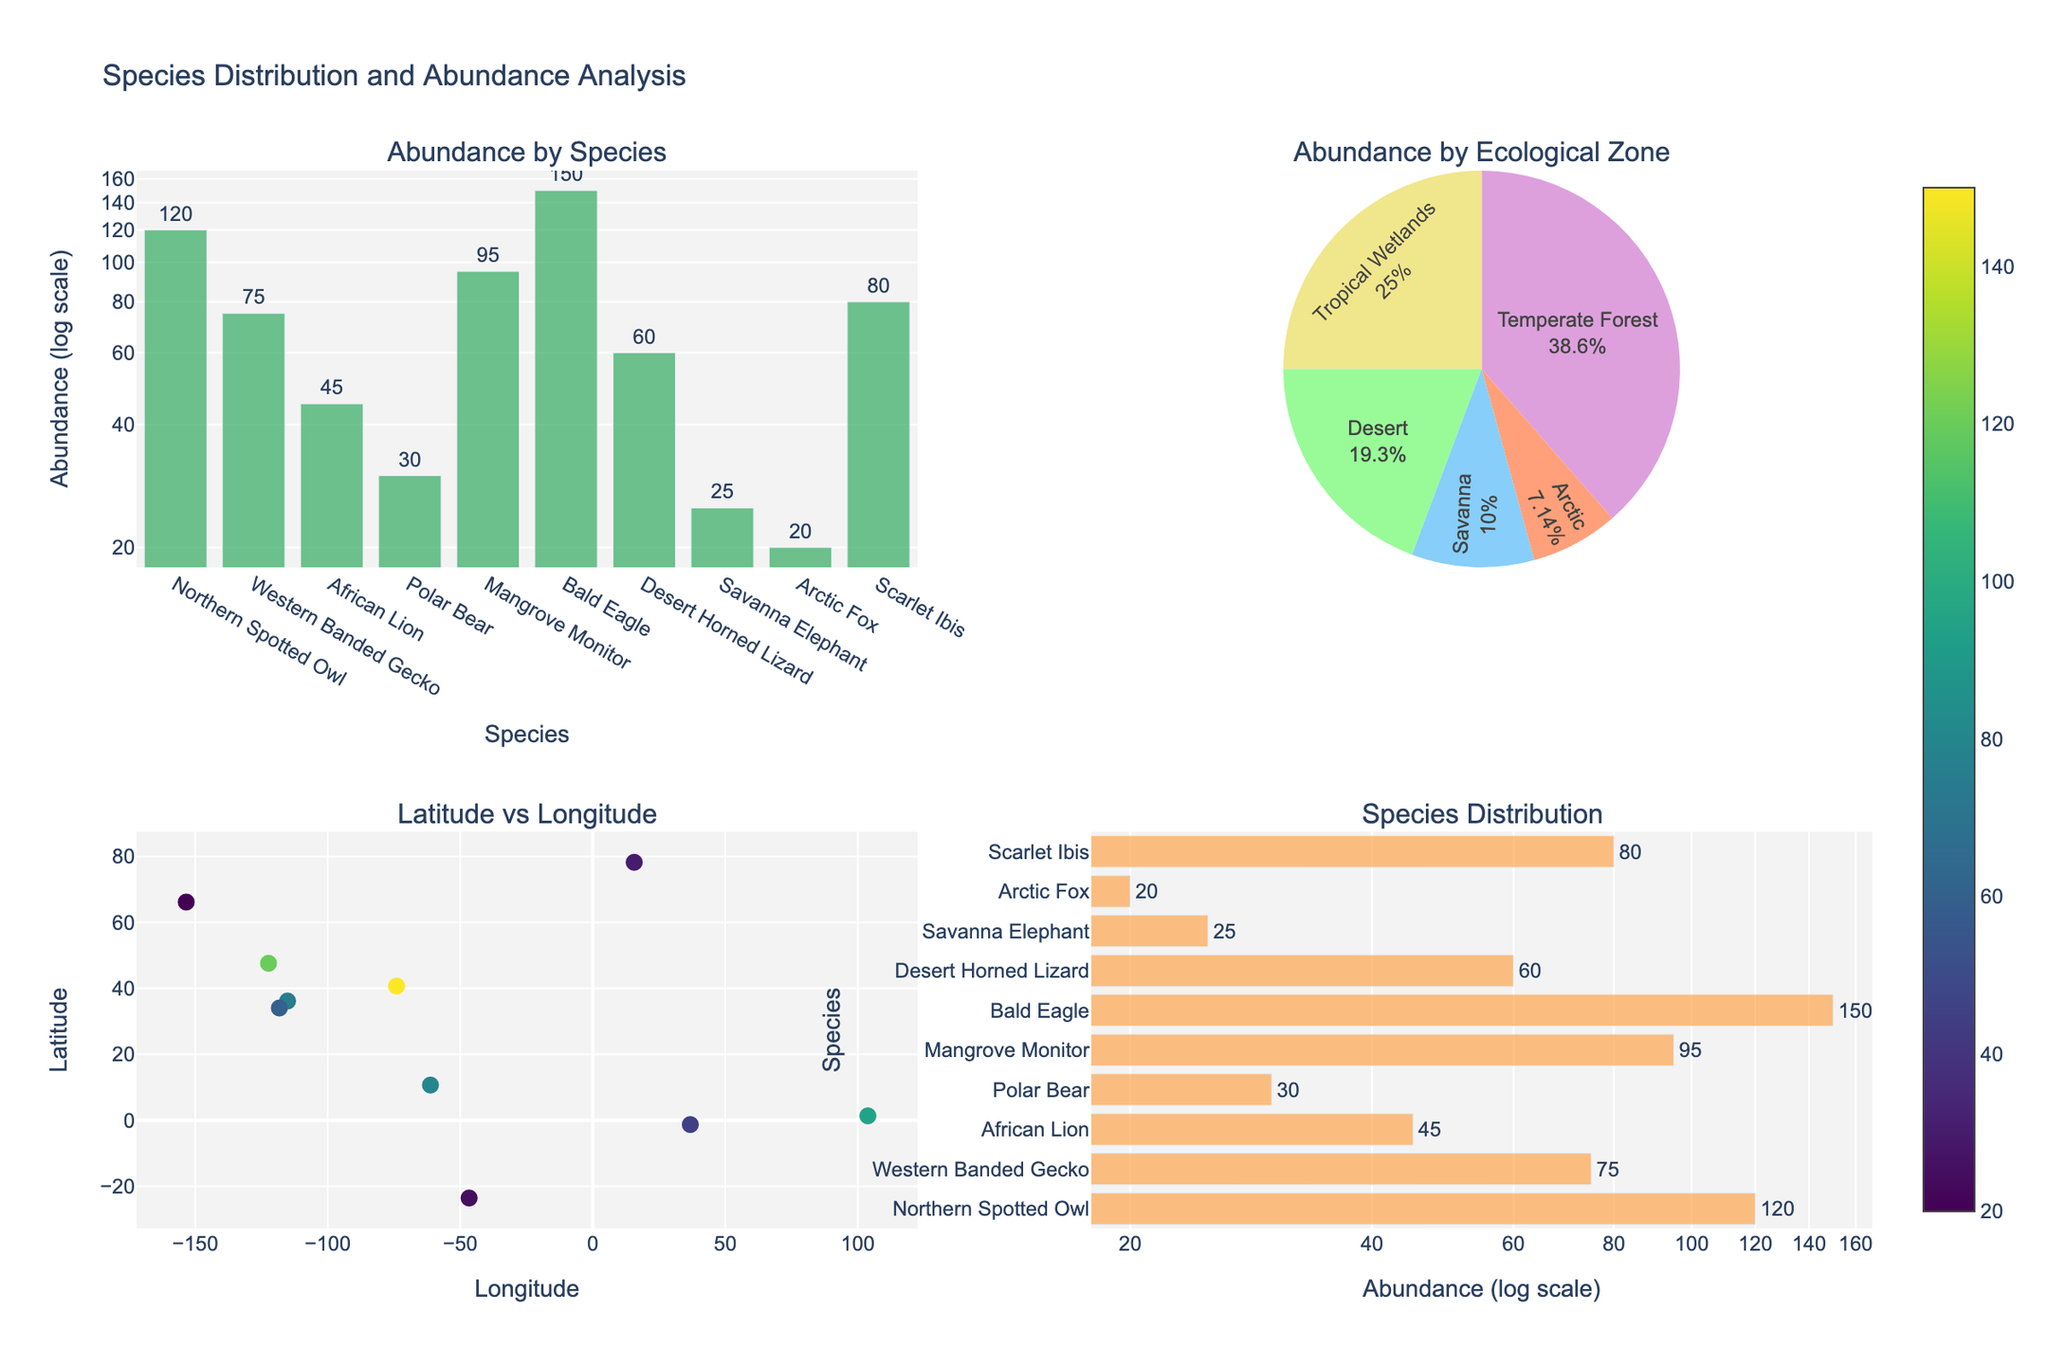What is the title of the figure? The title of the figure is displayed at the top and indicates the purpose of the figure. It reads "Species Distribution and Abundance Analysis".
Answer: Species Distribution and Abundance Analysis Which species has the highest abundance? Refer to the bar plot on the top left and the horizontal bar plot on the bottom right. The species with the largest bar is the Bald Eagle with 150.
Answer: Bald Eagle Which ecological zone has the highest total species abundance? Look at the pie chart in the top right section. The largest pie slice represents the Temperate Forest, which has the highest total abundance.
Answer: Temperate Forest What are the longitude and latitude coordinates for the African Lion? Check the scatter plot in the bottom left. Hovering over or identifying the data point for the African Lion, the coordinates are approximately 36.8219 longitude and -1.2921 latitude.
Answer: 36.8219, -1.2921 What is the total abundance of species in the Desert? Refer to the pie chart, which shows the total abundance for the Desert zone. It is 135 (75 + 60).
Answer: 135 How does the abundance of the Arctic Fox compare to the Polar Bear? Check the bar plots to compare their abundances. The Arctic Fox has an abundance of 20, which is lower than the Polar Bear's 30.
Answer: The Arctic Fox has a lower abundance than the Polar Bear By what factor does the abundance of the Bald Eagle exceed that of the Arctic Fox? Divide the abundance of the Bald Eagle (150) by the Arctic Fox (20). 150 divided by 20 is 7.5.
Answer: 7.5 Which ecological zone has the least abundance and what is its value? Refer to the pie chart again. The Savanna zone has the least abundance with a value of 70 (45 for African Lion + 25 for Savanna Elephant).
Answer: Savanna, 70 How are species distributed spatially in the scatter plot? The scatter plot in the bottom left shows the species spread across different longitudes (-153.3691 to 103.8198) and latitudes (10.6918 to 78.2232). Each marker represents a species, and the color intensity indicates its abundance.
Answer: Species are distributed across a wide range of latitudes and longitudes, with varying abundances 